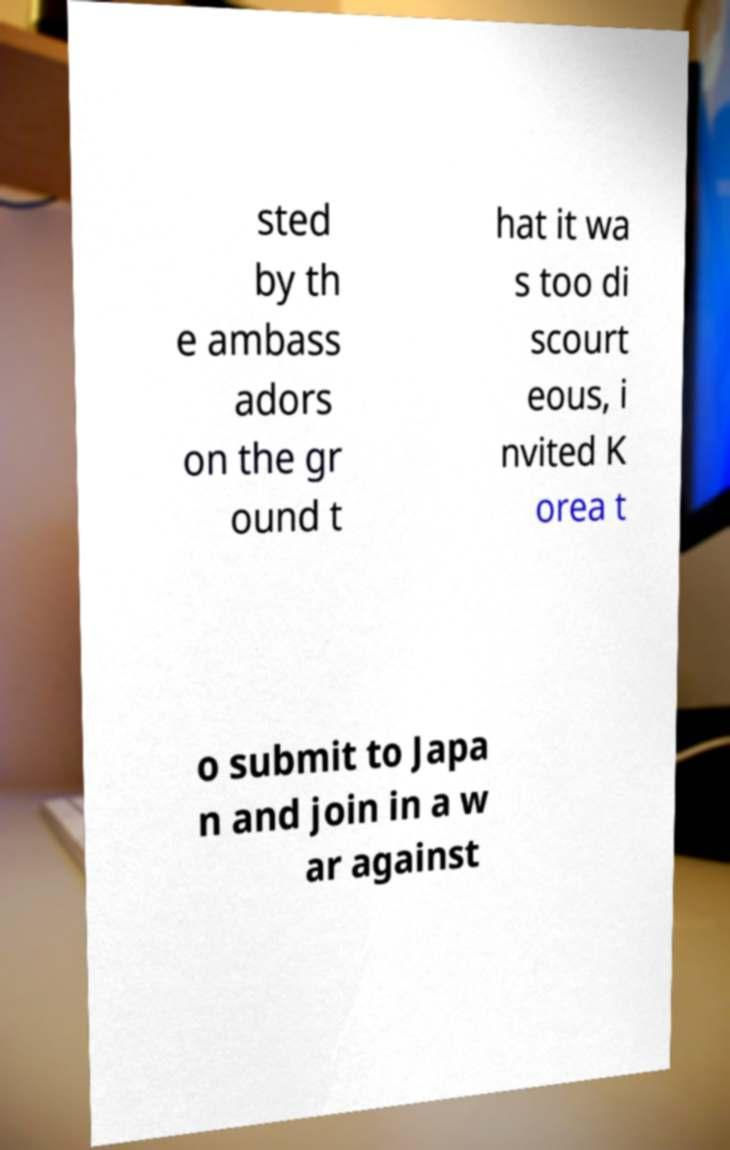Please identify and transcribe the text found in this image. sted by th e ambass adors on the gr ound t hat it wa s too di scourt eous, i nvited K orea t o submit to Japa n and join in a w ar against 